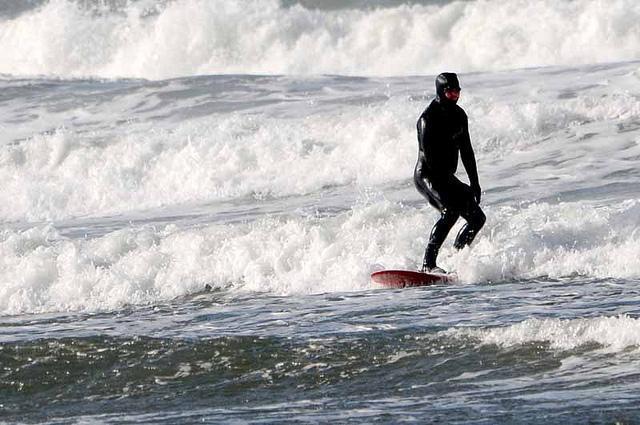How many sheep are there?
Give a very brief answer. 0. 